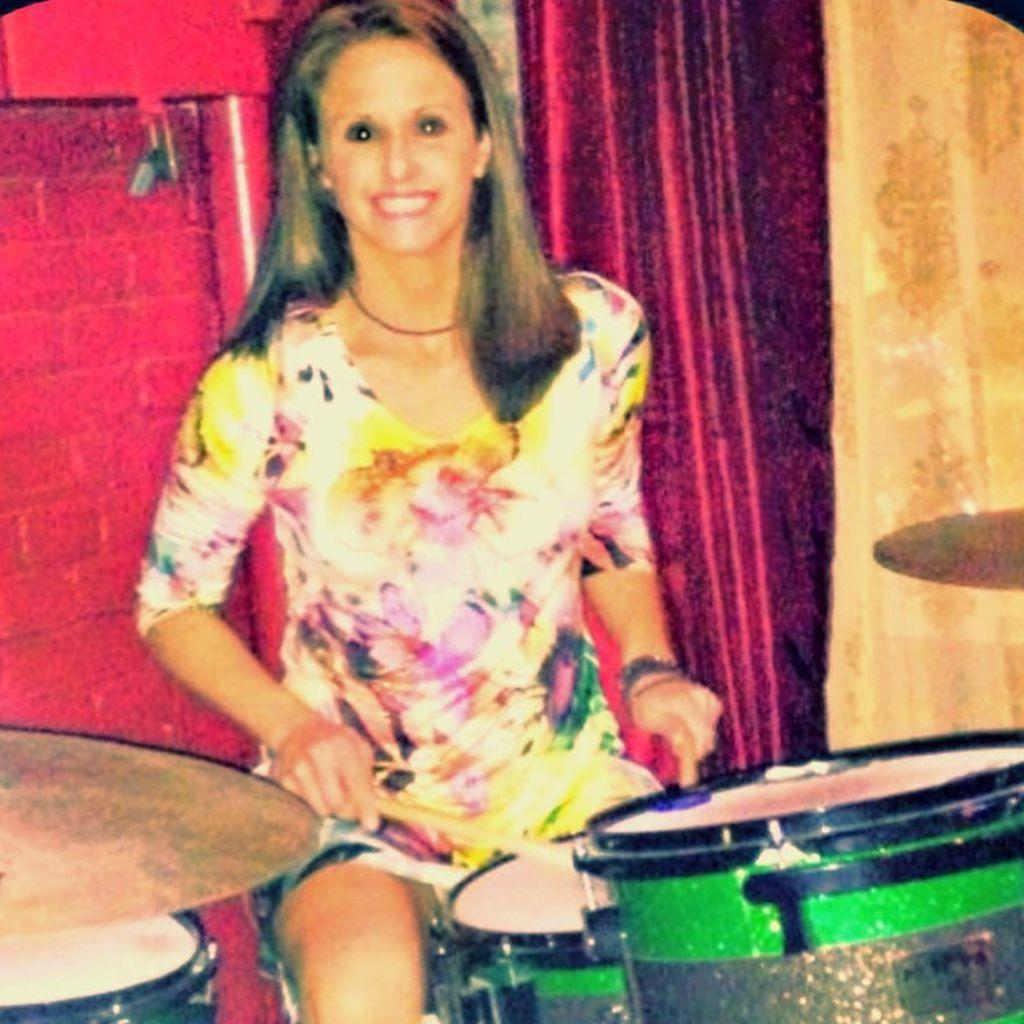Who is the main subject in the image? There is a woman in the image. What is the woman wearing? The woman is wearing a colorful dress. What is the woman's facial expression? The woman is smiling. What is the woman's hair like? The woman has short hair. What is the woman doing in the image? The woman is playing drums. What can be seen in the background of the image? There is a wall and a curtain in the background of the image. What type of eggs can be seen in the image? There are no eggs present in the image. Is there an airplane visible in the image? No, there is no airplane visible in the image. 